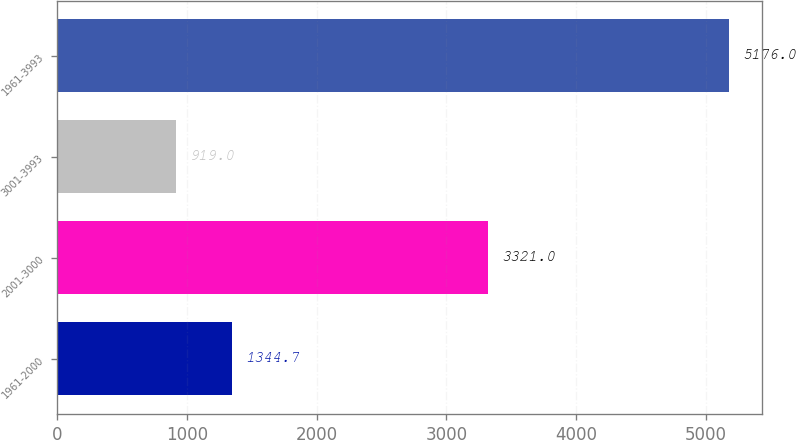<chart> <loc_0><loc_0><loc_500><loc_500><bar_chart><fcel>1961-2000<fcel>2001-3000<fcel>3001-3993<fcel>1961-3993<nl><fcel>1344.7<fcel>3321<fcel>919<fcel>5176<nl></chart> 